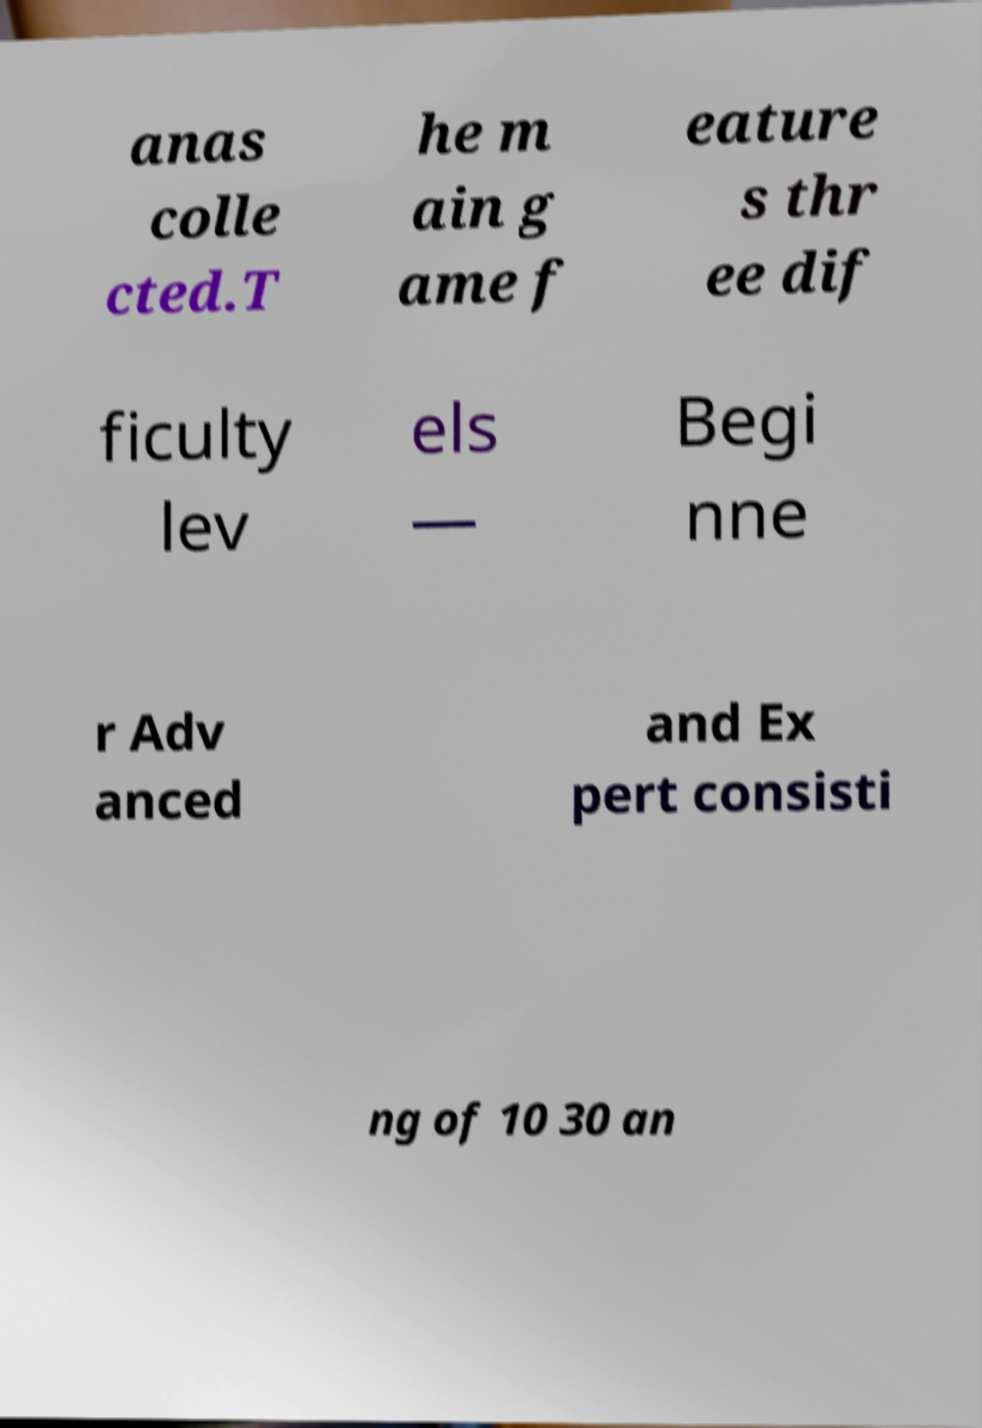Please read and relay the text visible in this image. What does it say? anas colle cted.T he m ain g ame f eature s thr ee dif ficulty lev els — Begi nne r Adv anced and Ex pert consisti ng of 10 30 an 